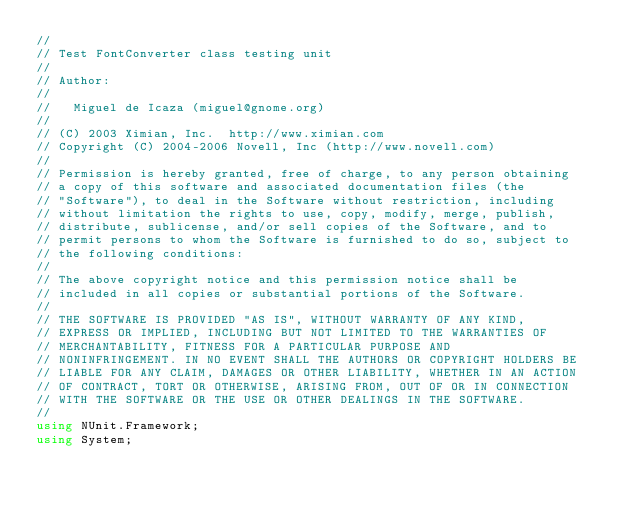Convert code to text. <code><loc_0><loc_0><loc_500><loc_500><_C#_>//
// Test FontConverter class testing unit
//
// Author:
//
// 	 Miguel de Icaza (miguel@gnome.org)
//
// (C) 2003 Ximian, Inc.  http://www.ximian.com
// Copyright (C) 2004-2006 Novell, Inc (http://www.novell.com)
//
// Permission is hereby granted, free of charge, to any person obtaining
// a copy of this software and associated documentation files (the
// "Software"), to deal in the Software without restriction, including
// without limitation the rights to use, copy, modify, merge, publish,
// distribute, sublicense, and/or sell copies of the Software, and to
// permit persons to whom the Software is furnished to do so, subject to
// the following conditions:
// 
// The above copyright notice and this permission notice shall be
// included in all copies or substantial portions of the Software.
// 
// THE SOFTWARE IS PROVIDED "AS IS", WITHOUT WARRANTY OF ANY KIND,
// EXPRESS OR IMPLIED, INCLUDING BUT NOT LIMITED TO THE WARRANTIES OF
// MERCHANTABILITY, FITNESS FOR A PARTICULAR PURPOSE AND
// NONINFRINGEMENT. IN NO EVENT SHALL THE AUTHORS OR COPYRIGHT HOLDERS BE
// LIABLE FOR ANY CLAIM, DAMAGES OR OTHER LIABILITY, WHETHER IN AN ACTION
// OF CONTRACT, TORT OR OTHERWISE, ARISING FROM, OUT OF OR IN CONNECTION
// WITH THE SOFTWARE OR THE USE OR OTHER DEALINGS IN THE SOFTWARE.
//
using NUnit.Framework;
using System;</code> 